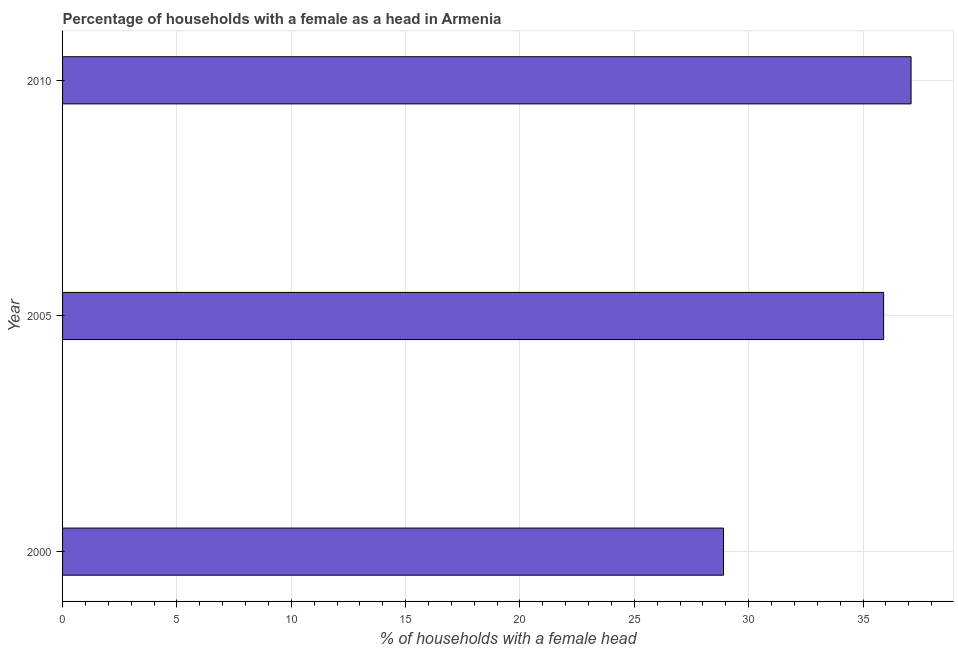Does the graph contain any zero values?
Offer a very short reply. No. What is the title of the graph?
Provide a short and direct response. Percentage of households with a female as a head in Armenia. What is the label or title of the X-axis?
Give a very brief answer. % of households with a female head. What is the number of female supervised households in 2000?
Give a very brief answer. 28.9. Across all years, what is the maximum number of female supervised households?
Ensure brevity in your answer.  37.1. Across all years, what is the minimum number of female supervised households?
Your answer should be compact. 28.9. In which year was the number of female supervised households maximum?
Provide a short and direct response. 2010. In which year was the number of female supervised households minimum?
Ensure brevity in your answer.  2000. What is the sum of the number of female supervised households?
Keep it short and to the point. 101.9. What is the average number of female supervised households per year?
Keep it short and to the point. 33.97. What is the median number of female supervised households?
Offer a terse response. 35.9. Do a majority of the years between 2000 and 2005 (inclusive) have number of female supervised households greater than 16 %?
Provide a succinct answer. Yes. Is the sum of the number of female supervised households in 2000 and 2005 greater than the maximum number of female supervised households across all years?
Provide a short and direct response. Yes. How many bars are there?
Your answer should be compact. 3. What is the % of households with a female head in 2000?
Offer a very short reply. 28.9. What is the % of households with a female head of 2005?
Make the answer very short. 35.9. What is the % of households with a female head in 2010?
Keep it short and to the point. 37.1. What is the difference between the % of households with a female head in 2005 and 2010?
Keep it short and to the point. -1.2. What is the ratio of the % of households with a female head in 2000 to that in 2005?
Make the answer very short. 0.81. What is the ratio of the % of households with a female head in 2000 to that in 2010?
Provide a succinct answer. 0.78. 